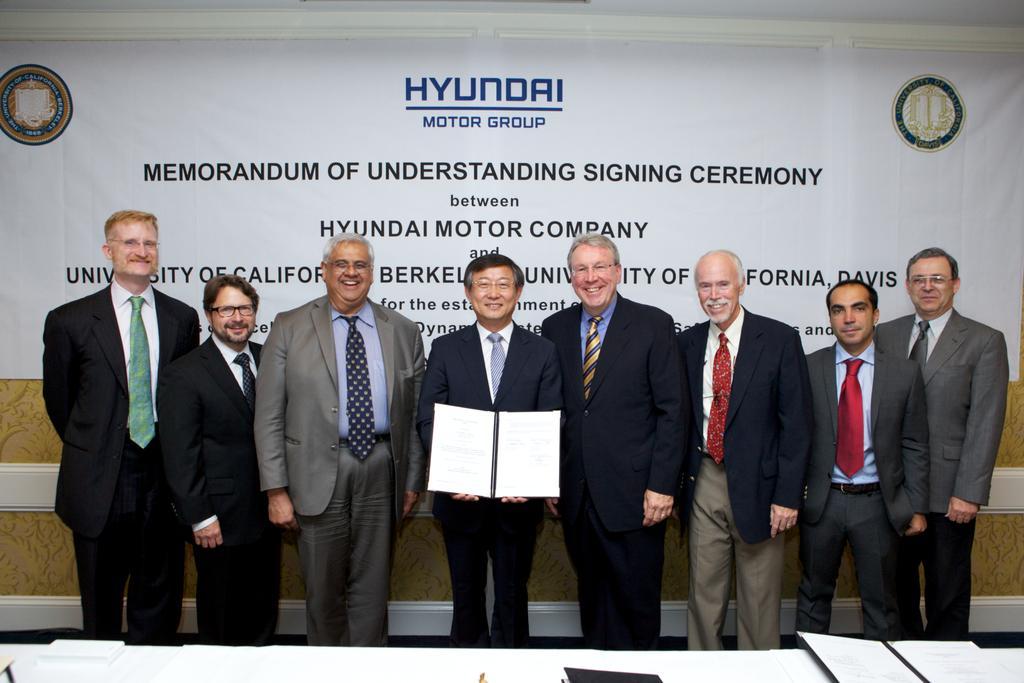Describe this image in one or two sentences. In the center of the image there are people standing wearing suits. In the background of the image there is a banner with some text on it. In front of the image there is a table on which there are books. 